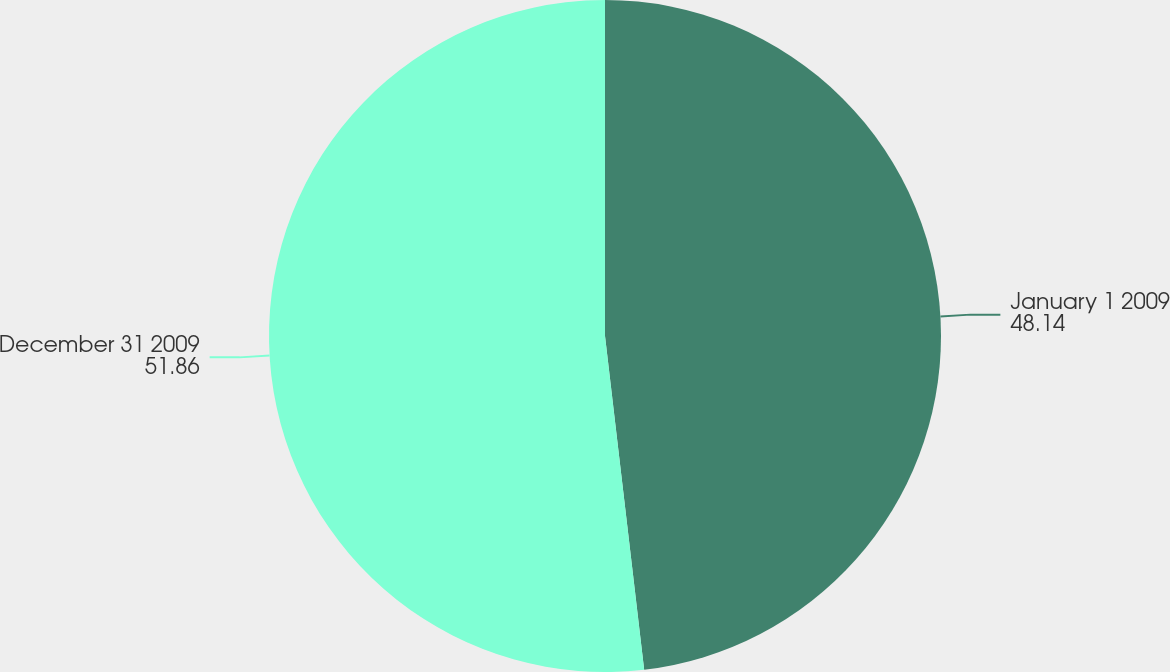Convert chart. <chart><loc_0><loc_0><loc_500><loc_500><pie_chart><fcel>January 1 2009<fcel>December 31 2009<nl><fcel>48.14%<fcel>51.86%<nl></chart> 